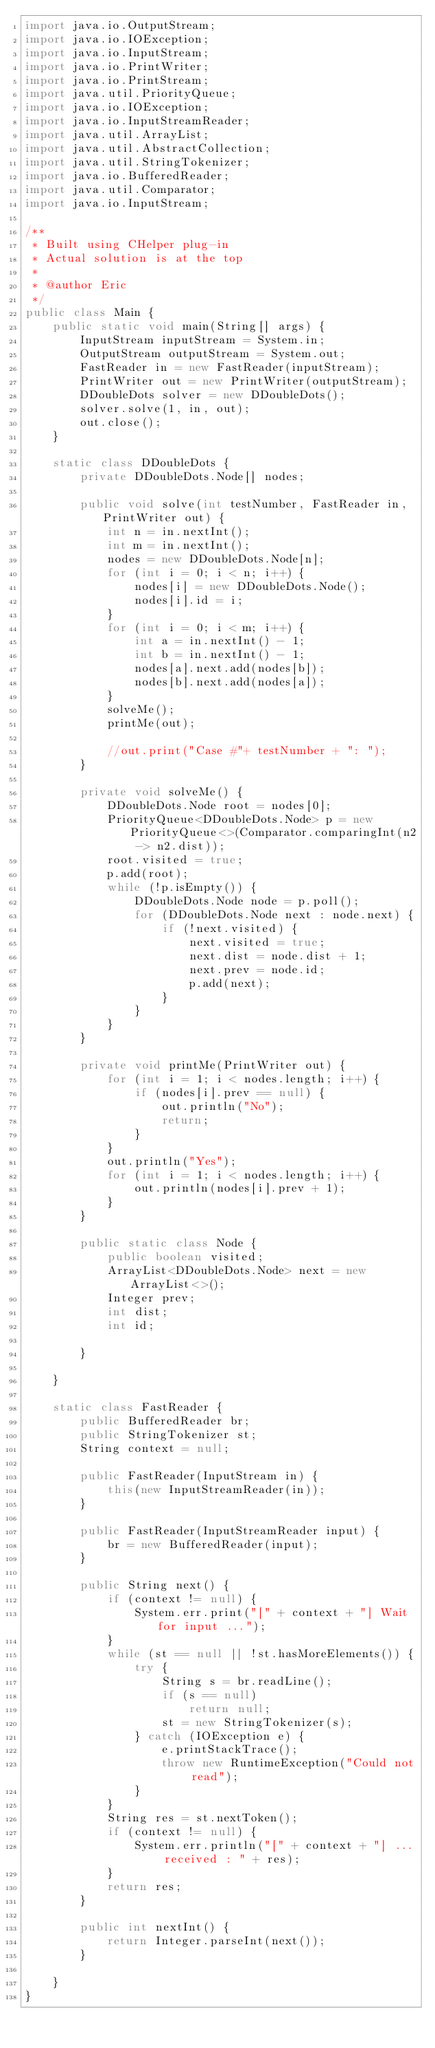Convert code to text. <code><loc_0><loc_0><loc_500><loc_500><_Java_>import java.io.OutputStream;
import java.io.IOException;
import java.io.InputStream;
import java.io.PrintWriter;
import java.io.PrintStream;
import java.util.PriorityQueue;
import java.io.IOException;
import java.io.InputStreamReader;
import java.util.ArrayList;
import java.util.AbstractCollection;
import java.util.StringTokenizer;
import java.io.BufferedReader;
import java.util.Comparator;
import java.io.InputStream;

/**
 * Built using CHelper plug-in
 * Actual solution is at the top
 *
 * @author Eric
 */
public class Main {
    public static void main(String[] args) {
        InputStream inputStream = System.in;
        OutputStream outputStream = System.out;
        FastReader in = new FastReader(inputStream);
        PrintWriter out = new PrintWriter(outputStream);
        DDoubleDots solver = new DDoubleDots();
        solver.solve(1, in, out);
        out.close();
    }

    static class DDoubleDots {
        private DDoubleDots.Node[] nodes;

        public void solve(int testNumber, FastReader in, PrintWriter out) {
            int n = in.nextInt();
            int m = in.nextInt();
            nodes = new DDoubleDots.Node[n];
            for (int i = 0; i < n; i++) {
                nodes[i] = new DDoubleDots.Node();
                nodes[i].id = i;
            }
            for (int i = 0; i < m; i++) {
                int a = in.nextInt() - 1;
                int b = in.nextInt() - 1;
                nodes[a].next.add(nodes[b]);
                nodes[b].next.add(nodes[a]);
            }
            solveMe();
            printMe(out);

            //out.print("Case #"+ testNumber + ": ");
        }

        private void solveMe() {
            DDoubleDots.Node root = nodes[0];
            PriorityQueue<DDoubleDots.Node> p = new PriorityQueue<>(Comparator.comparingInt(n2 -> n2.dist));
            root.visited = true;
            p.add(root);
            while (!p.isEmpty()) {
                DDoubleDots.Node node = p.poll();
                for (DDoubleDots.Node next : node.next) {
                    if (!next.visited) {
                        next.visited = true;
                        next.dist = node.dist + 1;
                        next.prev = node.id;
                        p.add(next);
                    }
                }
            }
        }

        private void printMe(PrintWriter out) {
            for (int i = 1; i < nodes.length; i++) {
                if (nodes[i].prev == null) {
                    out.println("No");
                    return;
                }
            }
            out.println("Yes");
            for (int i = 1; i < nodes.length; i++) {
                out.println(nodes[i].prev + 1);
            }
        }

        public static class Node {
            public boolean visited;
            ArrayList<DDoubleDots.Node> next = new ArrayList<>();
            Integer prev;
            int dist;
            int id;

        }

    }

    static class FastReader {
        public BufferedReader br;
        public StringTokenizer st;
        String context = null;

        public FastReader(InputStream in) {
            this(new InputStreamReader(in));
        }

        public FastReader(InputStreamReader input) {
            br = new BufferedReader(input);
        }

        public String next() {
            if (context != null) {
                System.err.print("[" + context + "] Wait for input ...");
            }
            while (st == null || !st.hasMoreElements()) {
                try {
                    String s = br.readLine();
                    if (s == null)
                        return null;
                    st = new StringTokenizer(s);
                } catch (IOException e) {
                    e.printStackTrace();
                    throw new RuntimeException("Could not read");
                }
            }
            String res = st.nextToken();
            if (context != null) {
                System.err.println("[" + context + "] ... received : " + res);
            }
            return res;
        }

        public int nextInt() {
            return Integer.parseInt(next());
        }

    }
}

</code> 